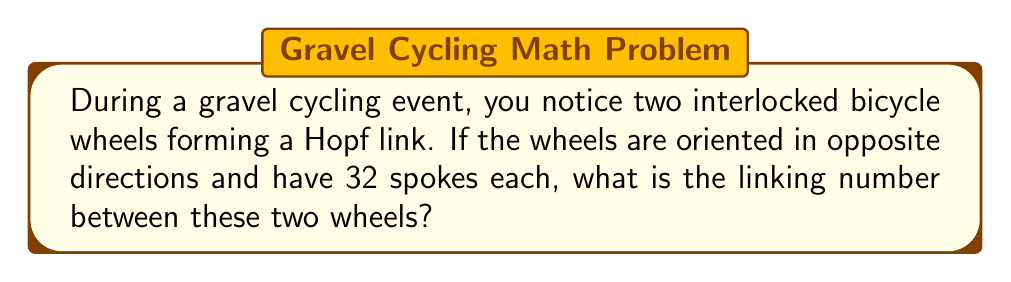Help me with this question. To solve this problem, we'll follow these steps:

1) First, recall that the linking number for a Hopf link is always ±1, depending on the orientation of the components.

2) In this case, the wheels are oriented in opposite directions, which means they form a positive Hopf link.

3) The linking number is defined as:

   $$ Lk(K_1, K_2) = \frac{1}{2} \sum_{p \in K_1 \cap K_2} \varepsilon(p) $$

   where $K_1$ and $K_2$ are the two components (wheels in this case), and $\varepsilon(p)$ is the sign of each crossing (+1 for right-handed, -1 for left-handed).

4) In a Hopf link, there are two crossings, both of which are right-handed in a positive Hopf link.

5) Therefore, the sum of the crossing signs is:

   $$ \sum_{p \in K_1 \cap K_2} \varepsilon(p) = (+1) + (+1) = 2 $$

6) Applying the formula:

   $$ Lk(K_1, K_2) = \frac{1}{2} (2) = 1 $$

7) Note that the number of spokes (32 for each wheel) doesn't affect the linking number, as we're considering the wheels as simple closed curves for this calculation.
Answer: 1 